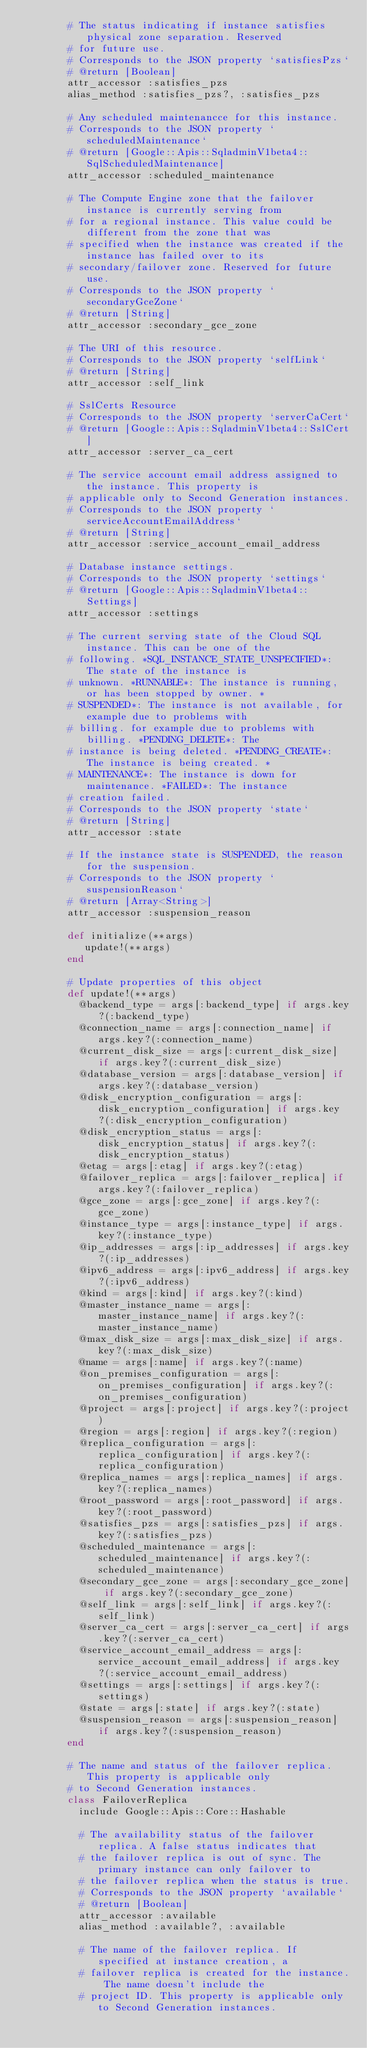<code> <loc_0><loc_0><loc_500><loc_500><_Ruby_>        # The status indicating if instance satisfies physical zone separation. Reserved
        # for future use.
        # Corresponds to the JSON property `satisfiesPzs`
        # @return [Boolean]
        attr_accessor :satisfies_pzs
        alias_method :satisfies_pzs?, :satisfies_pzs
      
        # Any scheduled maintenancce for this instance.
        # Corresponds to the JSON property `scheduledMaintenance`
        # @return [Google::Apis::SqladminV1beta4::SqlScheduledMaintenance]
        attr_accessor :scheduled_maintenance
      
        # The Compute Engine zone that the failover instance is currently serving from
        # for a regional instance. This value could be different from the zone that was
        # specified when the instance was created if the instance has failed over to its
        # secondary/failover zone. Reserved for future use.
        # Corresponds to the JSON property `secondaryGceZone`
        # @return [String]
        attr_accessor :secondary_gce_zone
      
        # The URI of this resource.
        # Corresponds to the JSON property `selfLink`
        # @return [String]
        attr_accessor :self_link
      
        # SslCerts Resource
        # Corresponds to the JSON property `serverCaCert`
        # @return [Google::Apis::SqladminV1beta4::SslCert]
        attr_accessor :server_ca_cert
      
        # The service account email address assigned to the instance. This property is
        # applicable only to Second Generation instances.
        # Corresponds to the JSON property `serviceAccountEmailAddress`
        # @return [String]
        attr_accessor :service_account_email_address
      
        # Database instance settings.
        # Corresponds to the JSON property `settings`
        # @return [Google::Apis::SqladminV1beta4::Settings]
        attr_accessor :settings
      
        # The current serving state of the Cloud SQL instance. This can be one of the
        # following. *SQL_INSTANCE_STATE_UNSPECIFIED*: The state of the instance is
        # unknown. *RUNNABLE*: The instance is running, or has been stopped by owner. *
        # SUSPENDED*: The instance is not available, for example due to problems with
        # billing. for example due to problems with billing. *PENDING_DELETE*: The
        # instance is being deleted. *PENDING_CREATE*: The instance is being created. *
        # MAINTENANCE*: The instance is down for maintenance. *FAILED*: The instance
        # creation failed.
        # Corresponds to the JSON property `state`
        # @return [String]
        attr_accessor :state
      
        # If the instance state is SUSPENDED, the reason for the suspension.
        # Corresponds to the JSON property `suspensionReason`
        # @return [Array<String>]
        attr_accessor :suspension_reason
      
        def initialize(**args)
           update!(**args)
        end
      
        # Update properties of this object
        def update!(**args)
          @backend_type = args[:backend_type] if args.key?(:backend_type)
          @connection_name = args[:connection_name] if args.key?(:connection_name)
          @current_disk_size = args[:current_disk_size] if args.key?(:current_disk_size)
          @database_version = args[:database_version] if args.key?(:database_version)
          @disk_encryption_configuration = args[:disk_encryption_configuration] if args.key?(:disk_encryption_configuration)
          @disk_encryption_status = args[:disk_encryption_status] if args.key?(:disk_encryption_status)
          @etag = args[:etag] if args.key?(:etag)
          @failover_replica = args[:failover_replica] if args.key?(:failover_replica)
          @gce_zone = args[:gce_zone] if args.key?(:gce_zone)
          @instance_type = args[:instance_type] if args.key?(:instance_type)
          @ip_addresses = args[:ip_addresses] if args.key?(:ip_addresses)
          @ipv6_address = args[:ipv6_address] if args.key?(:ipv6_address)
          @kind = args[:kind] if args.key?(:kind)
          @master_instance_name = args[:master_instance_name] if args.key?(:master_instance_name)
          @max_disk_size = args[:max_disk_size] if args.key?(:max_disk_size)
          @name = args[:name] if args.key?(:name)
          @on_premises_configuration = args[:on_premises_configuration] if args.key?(:on_premises_configuration)
          @project = args[:project] if args.key?(:project)
          @region = args[:region] if args.key?(:region)
          @replica_configuration = args[:replica_configuration] if args.key?(:replica_configuration)
          @replica_names = args[:replica_names] if args.key?(:replica_names)
          @root_password = args[:root_password] if args.key?(:root_password)
          @satisfies_pzs = args[:satisfies_pzs] if args.key?(:satisfies_pzs)
          @scheduled_maintenance = args[:scheduled_maintenance] if args.key?(:scheduled_maintenance)
          @secondary_gce_zone = args[:secondary_gce_zone] if args.key?(:secondary_gce_zone)
          @self_link = args[:self_link] if args.key?(:self_link)
          @server_ca_cert = args[:server_ca_cert] if args.key?(:server_ca_cert)
          @service_account_email_address = args[:service_account_email_address] if args.key?(:service_account_email_address)
          @settings = args[:settings] if args.key?(:settings)
          @state = args[:state] if args.key?(:state)
          @suspension_reason = args[:suspension_reason] if args.key?(:suspension_reason)
        end
        
        # The name and status of the failover replica. This property is applicable only
        # to Second Generation instances.
        class FailoverReplica
          include Google::Apis::Core::Hashable
        
          # The availability status of the failover replica. A false status indicates that
          # the failover replica is out of sync. The primary instance can only failover to
          # the failover replica when the status is true.
          # Corresponds to the JSON property `available`
          # @return [Boolean]
          attr_accessor :available
          alias_method :available?, :available
        
          # The name of the failover replica. If specified at instance creation, a
          # failover replica is created for the instance. The name doesn't include the
          # project ID. This property is applicable only to Second Generation instances.</code> 